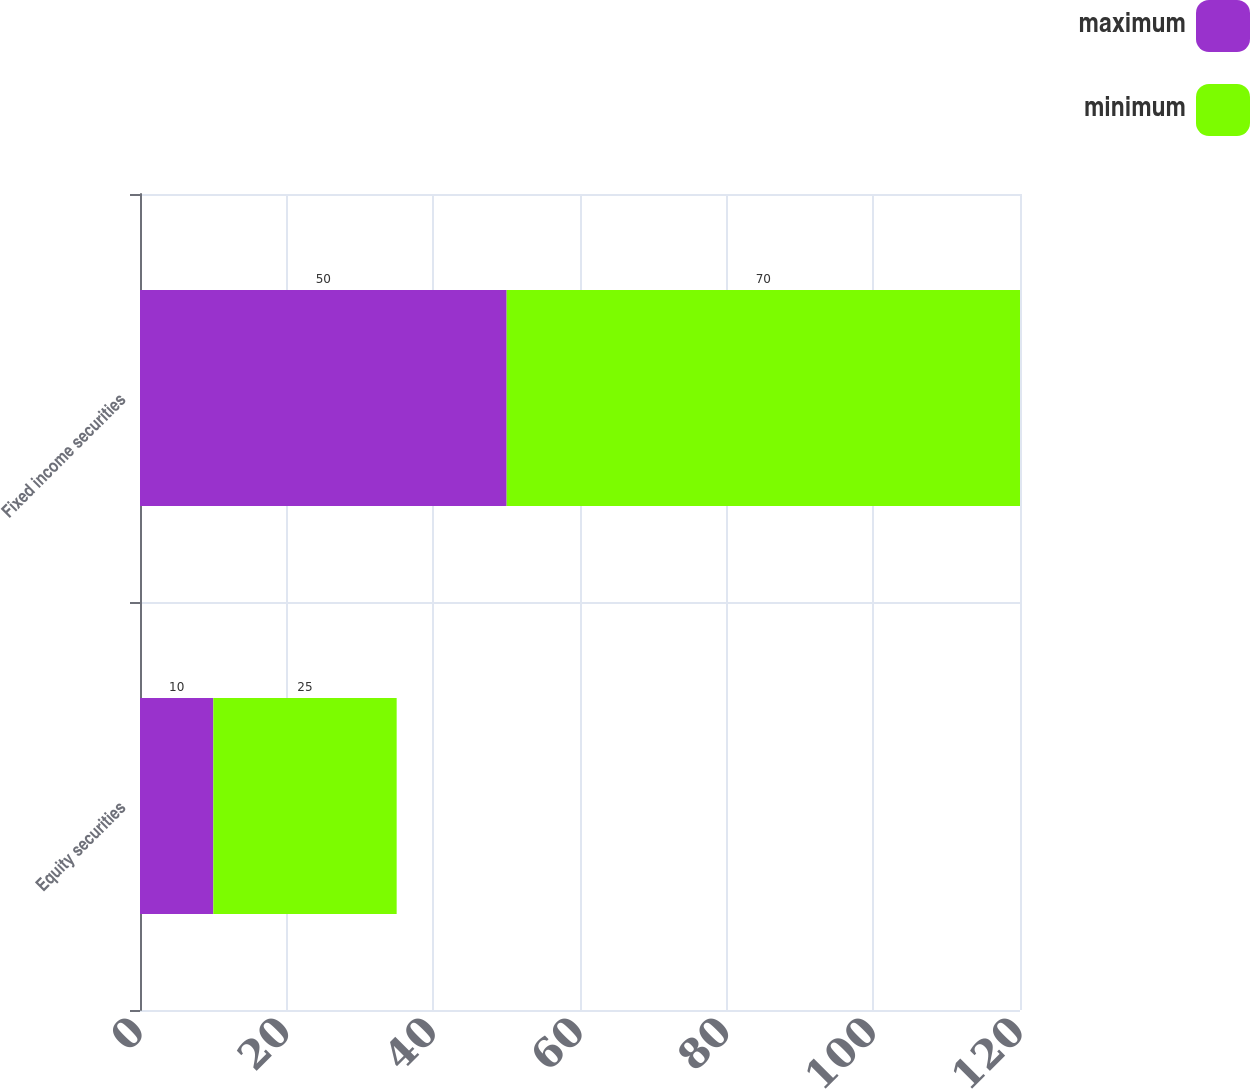Convert chart. <chart><loc_0><loc_0><loc_500><loc_500><stacked_bar_chart><ecel><fcel>Equity securities<fcel>Fixed income securities<nl><fcel>maximum<fcel>10<fcel>50<nl><fcel>minimum<fcel>25<fcel>70<nl></chart> 